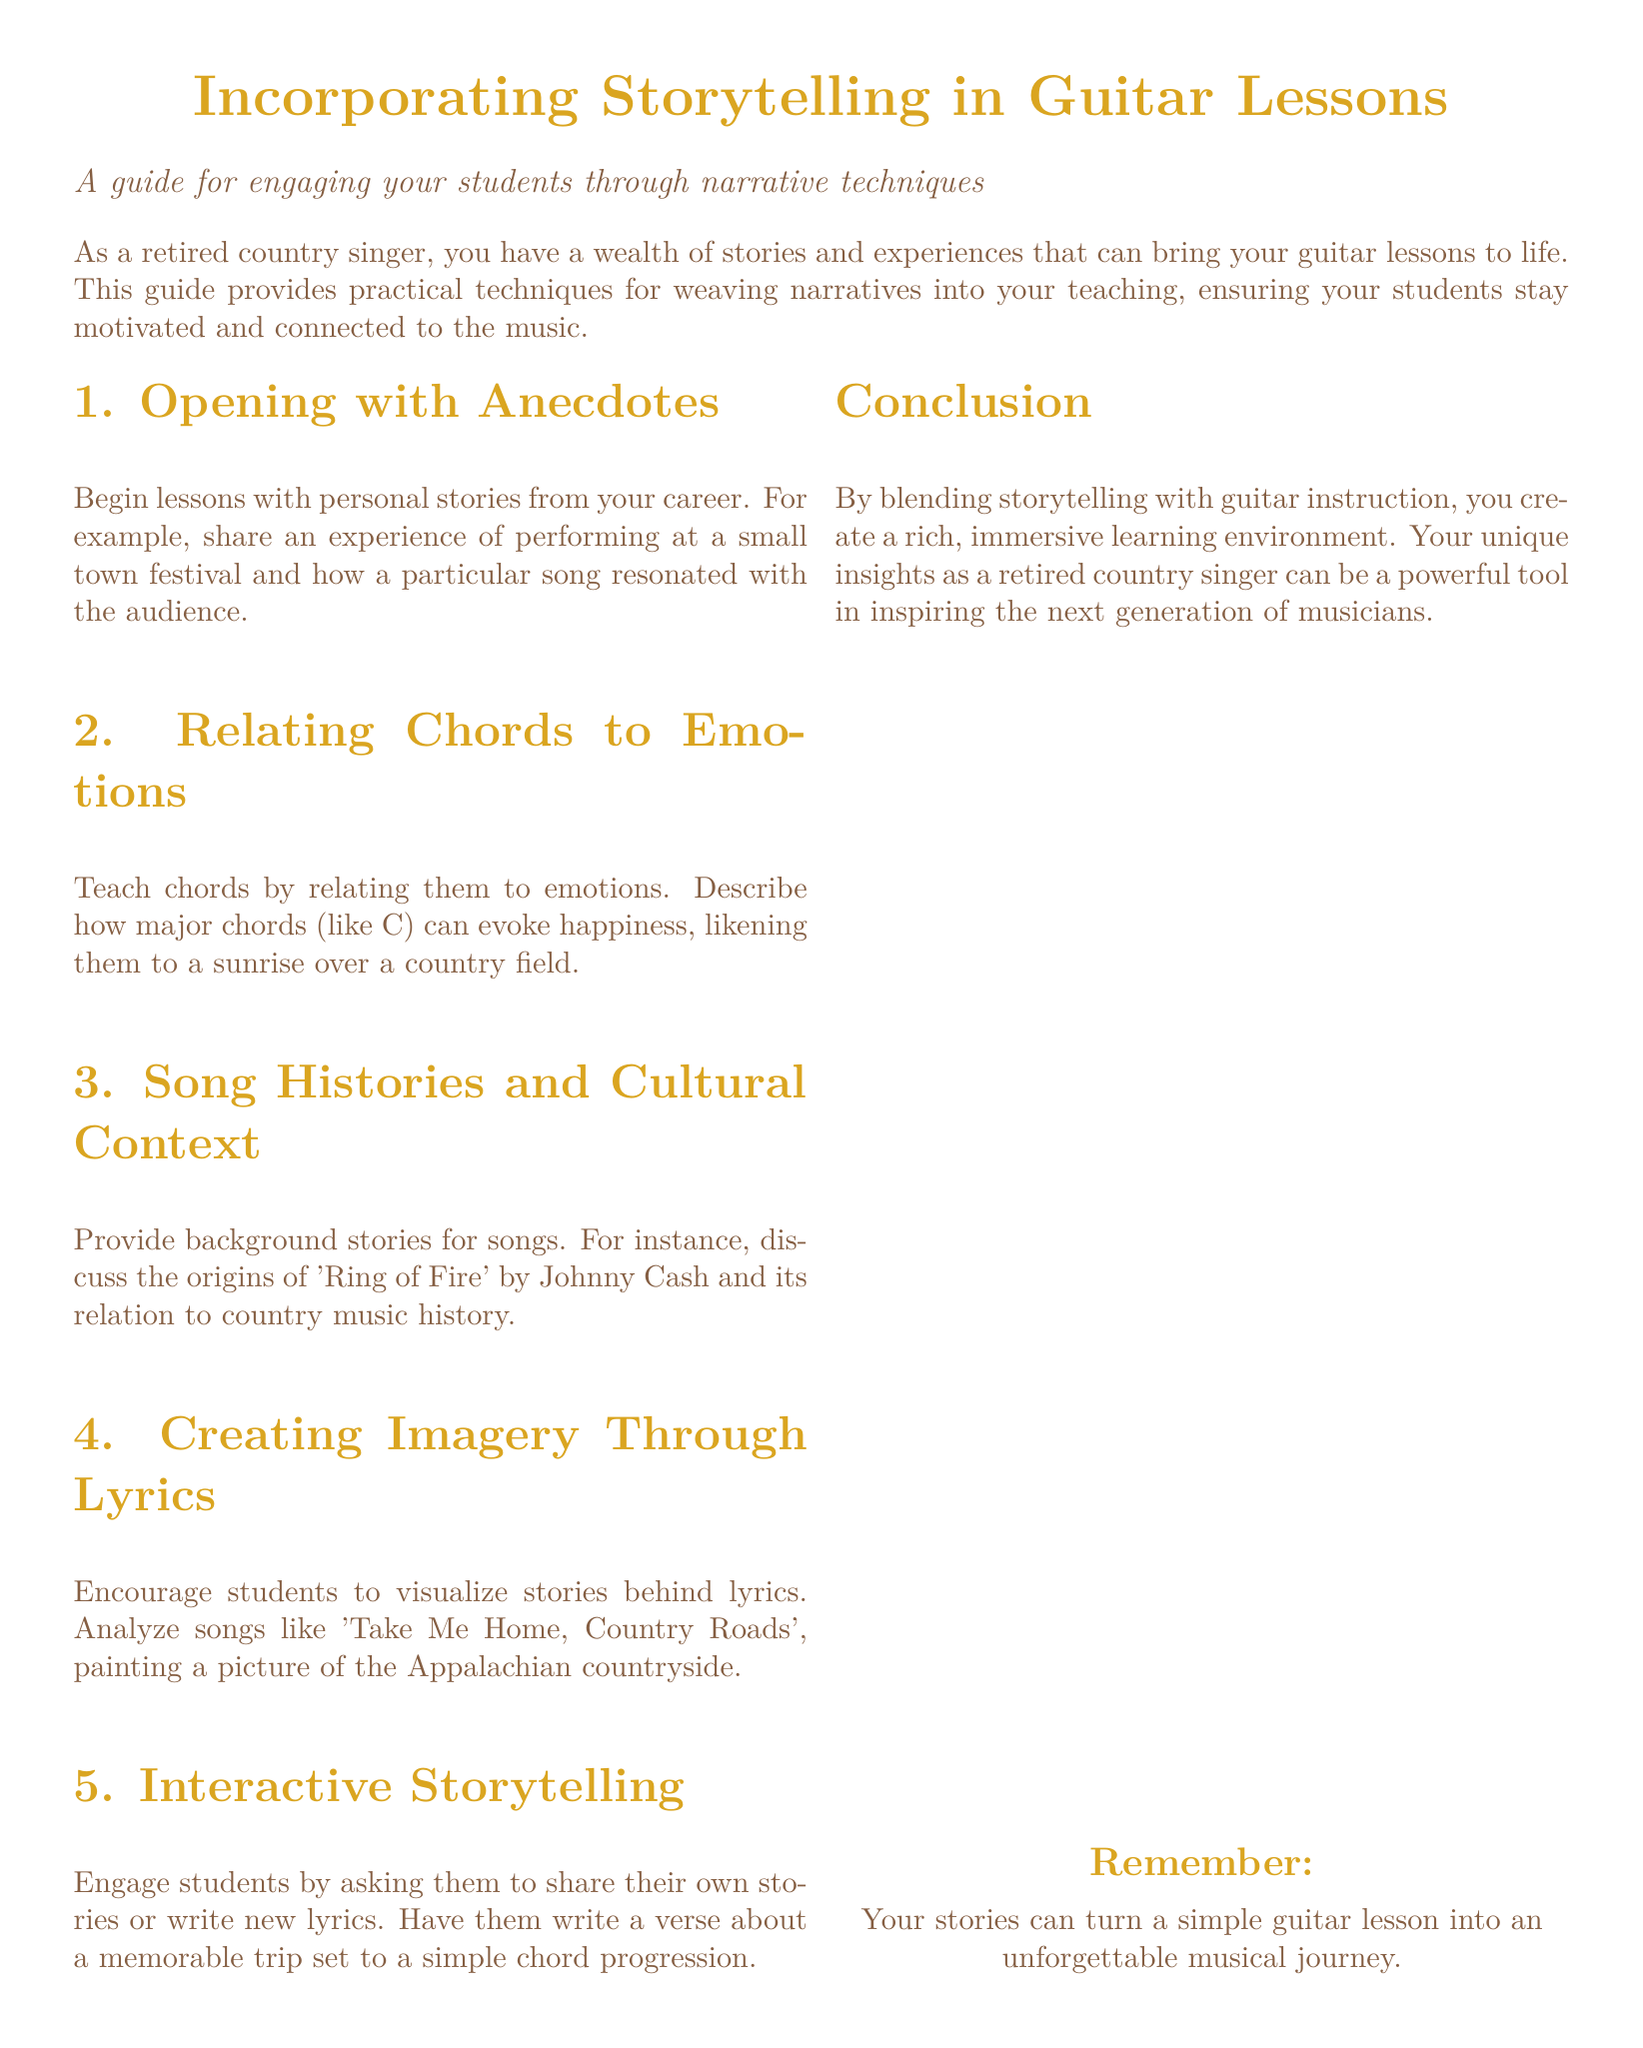What is the title of the guide? The title is found at the top of the document in a larger font size, stating the focus of the content.
Answer: Incorporating Storytelling in Guitar Lessons What is one method suggested for engaging students? The guide lists various techniques for engagement, highlighting the importance of storytelling in lessons.
Answer: Opening with Anecdotes Which song is mentioned in relation to its cultural context? The guide provides an example of a classic song and its significance within country music history.
Answer: Ring of Fire How can major chords be emotionally related according to the guide? The document explains the emotional connections and analogies made around certain chords like major chords.
Answer: Happiness What interactive activity is suggested in the guide? The document proposes a way for students to contribute creatively by incorporating their personal stories.
Answer: Writing new lyrics How many sections are provided in the guide? The number of sections can be counted from the content layout in the guide.
Answer: Five What color is used for section titles in the document? The document describes the color used for formatting section titles, which contributes to its aesthetic.
Answer: Country gold What is the primary goal of incorporating storytelling in lessons? The document emphasizes the overall benefit of storytelling for creating a richer learning experience.
Answer: Inspire students What type of document is this? The structure and content clearly categorize the document's purpose for instructional aid.
Answer: User guide 